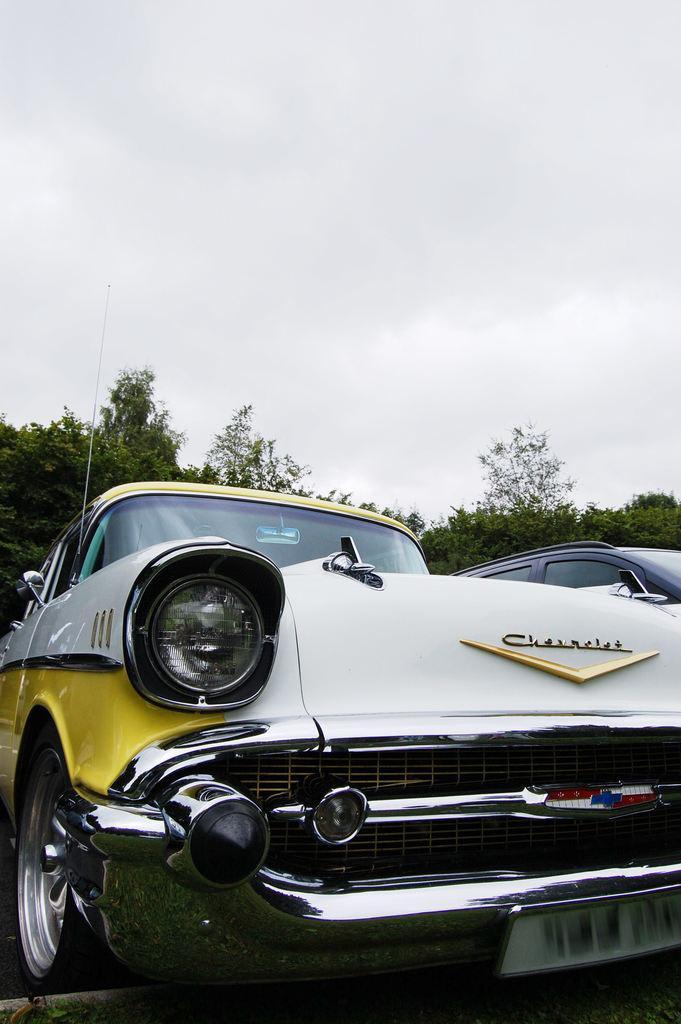Describe this image in one or two sentences. Here we can see cars and trees. In the background there is sky. 